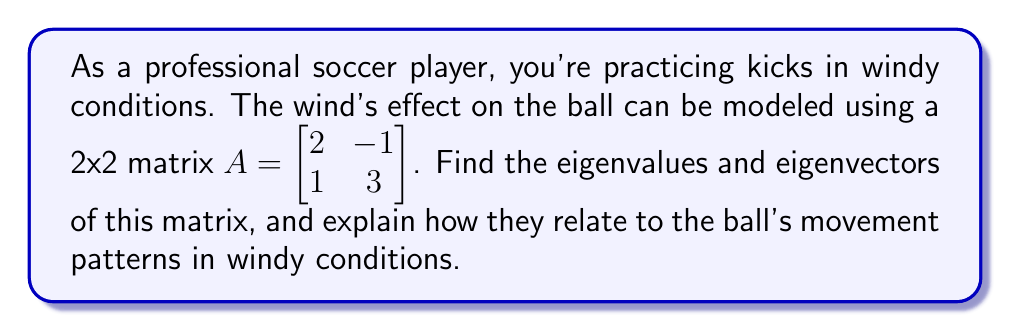Can you answer this question? To find the eigenvalues and eigenvectors of matrix $A$, we follow these steps:

1) First, we find the eigenvalues by solving the characteristic equation:
   $$det(A - \lambda I) = 0$$
   
   Where $I$ is the 2x2 identity matrix and $\lambda$ represents the eigenvalues.

2) Expanding this:
   $$\begin{vmatrix} 
   2-\lambda & -1 \\
   1 & 3-\lambda
   \end{vmatrix} = 0$$

3) This gives us:
   $$(2-\lambda)(3-\lambda) - (-1)(1) = 0$$
   $$\lambda^2 - 5\lambda + 5 = 0$$

4) Solving this quadratic equation:
   $$\lambda = \frac{5 \pm \sqrt{25 - 20}}{2} = \frac{5 \pm \sqrt{5}}{2}$$

5) So, the eigenvalues are:
   $$\lambda_1 = \frac{5 + \sqrt{5}}{2} \approx 3.618$$
   $$\lambda_2 = \frac{5 - \sqrt{5}}{2} \approx 1.382$$

6) Now, for each eigenvalue, we find the corresponding eigenvector by solving:
   $$(A - \lambda I)v = 0$$

7) For $\lambda_1$:
   $$\begin{bmatrix} 
   2-\frac{5+\sqrt{5}}{2} & -1 \\
   1 & 3-\frac{5+\sqrt{5}}{2}
   \end{bmatrix} \begin{bmatrix} 
   v_1 \\
   v_2
   \end{bmatrix} = \begin{bmatrix} 
   0 \\
   0
   \end{bmatrix}$$

8) Solving this, we get the eigenvector:
   $$v_1 = \begin{bmatrix} 
   \frac{\sqrt{5}+1}{2} \\
   1
   \end{bmatrix}$$

9) Similarly, for $\lambda_2$, we get:
   $$v_2 = \begin{bmatrix} 
   \frac{\sqrt{5}-1}{2} \\
   1
   \end{bmatrix}$$

In the context of ball movement in windy conditions:
- The eigenvectors represent the principal directions of the wind's effect on the ball.
- The eigenvalues represent the strength of the wind's effect in these directions.
- The larger eigenvalue ($\lambda_1$) corresponds to the direction where the wind has a stronger effect, potentially causing the ball to deviate more from its intended path.
- The smaller eigenvalue ($\lambda_2$) corresponds to the direction where the wind has a weaker effect.

Understanding these eigenvalues and eigenvectors can help a soccer player predict how the ball might behave in windy conditions and adjust their kicks accordingly.
Answer: Eigenvalues: $\lambda_1 = \frac{5 + \sqrt{5}}{2}, \lambda_2 = \frac{5 - \sqrt{5}}{2}$

Eigenvectors: $v_1 = \begin{bmatrix} 
\frac{\sqrt{5}+1}{2} \\
1
\end{bmatrix}, v_2 = \begin{bmatrix} 
\frac{\sqrt{5}-1}{2} \\
1
\end{bmatrix}$ 